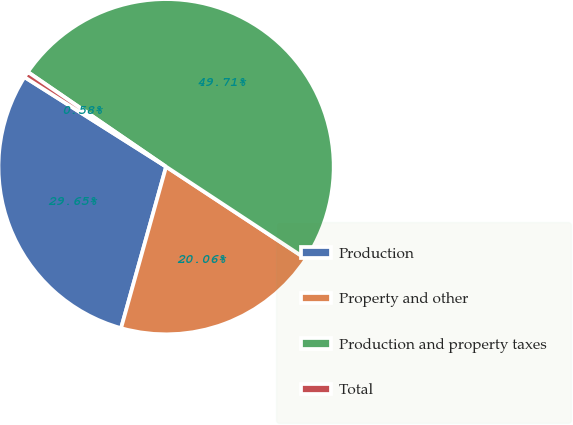<chart> <loc_0><loc_0><loc_500><loc_500><pie_chart><fcel>Production<fcel>Property and other<fcel>Production and property taxes<fcel>Total<nl><fcel>29.65%<fcel>20.06%<fcel>49.71%<fcel>0.58%<nl></chart> 